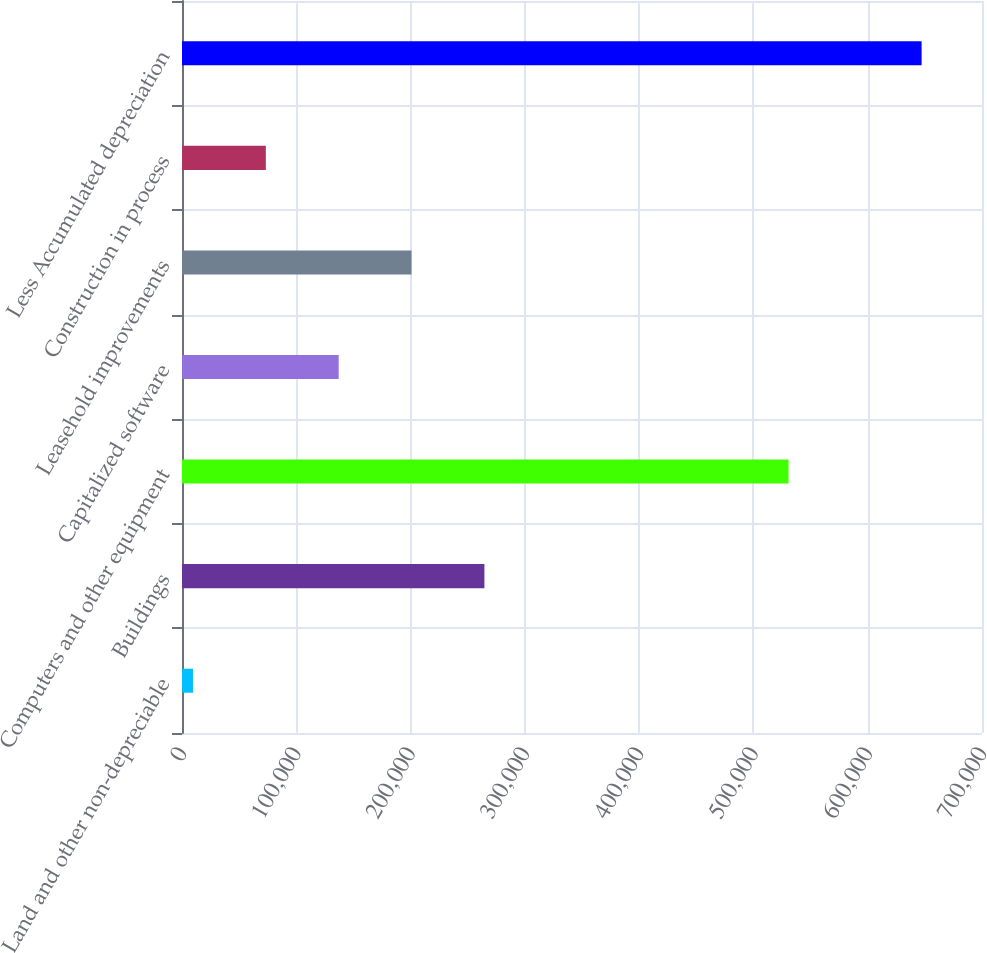Convert chart to OTSL. <chart><loc_0><loc_0><loc_500><loc_500><bar_chart><fcel>Land and other non-depreciable<fcel>Buildings<fcel>Computers and other equipment<fcel>Capitalized software<fcel>Leasehold improvements<fcel>Construction in process<fcel>Less Accumulated depreciation<nl><fcel>9592<fcel>264616<fcel>530713<fcel>137104<fcel>200860<fcel>73347.9<fcel>647151<nl></chart> 